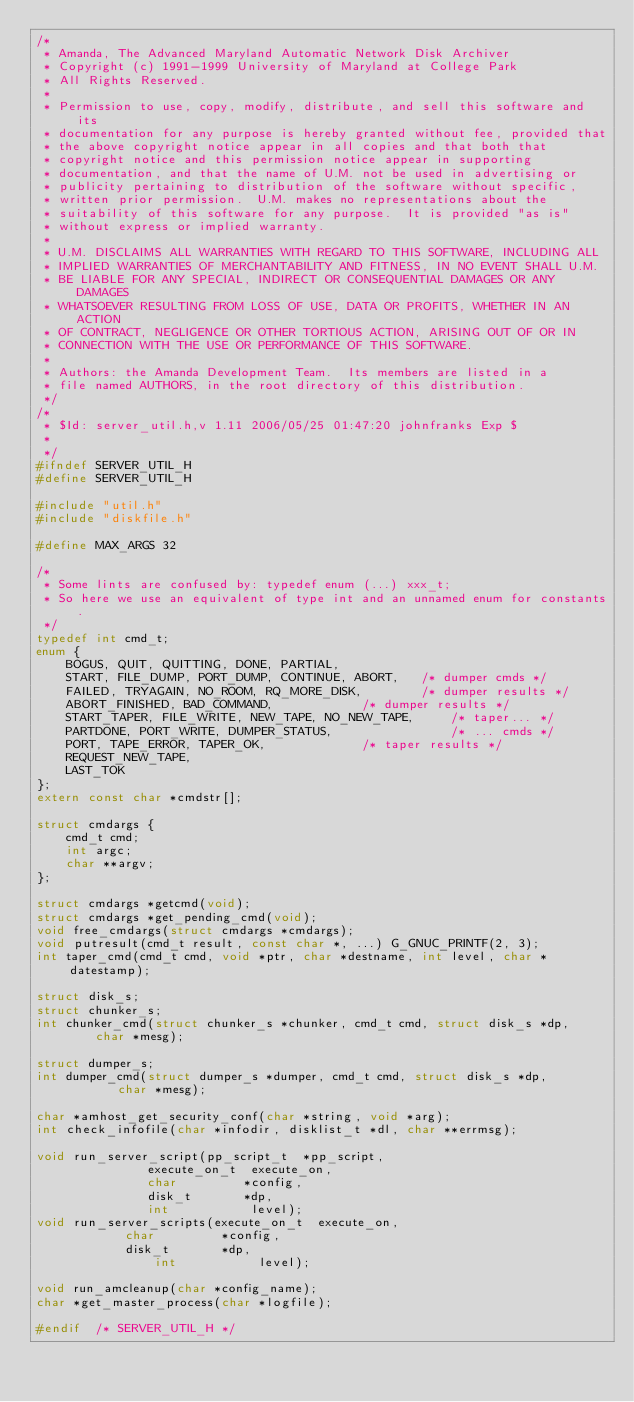<code> <loc_0><loc_0><loc_500><loc_500><_C_>/*
 * Amanda, The Advanced Maryland Automatic Network Disk Archiver
 * Copyright (c) 1991-1999 University of Maryland at College Park
 * All Rights Reserved.
 *
 * Permission to use, copy, modify, distribute, and sell this software and its
 * documentation for any purpose is hereby granted without fee, provided that
 * the above copyright notice appear in all copies and that both that
 * copyright notice and this permission notice appear in supporting
 * documentation, and that the name of U.M. not be used in advertising or
 * publicity pertaining to distribution of the software without specific,
 * written prior permission.  U.M. makes no representations about the
 * suitability of this software for any purpose.  It is provided "as is"
 * without express or implied warranty.
 *
 * U.M. DISCLAIMS ALL WARRANTIES WITH REGARD TO THIS SOFTWARE, INCLUDING ALL
 * IMPLIED WARRANTIES OF MERCHANTABILITY AND FITNESS, IN NO EVENT SHALL U.M.
 * BE LIABLE FOR ANY SPECIAL, INDIRECT OR CONSEQUENTIAL DAMAGES OR ANY DAMAGES
 * WHATSOEVER RESULTING FROM LOSS OF USE, DATA OR PROFITS, WHETHER IN AN ACTION
 * OF CONTRACT, NEGLIGENCE OR OTHER TORTIOUS ACTION, ARISING OUT OF OR IN
 * CONNECTION WITH THE USE OR PERFORMANCE OF THIS SOFTWARE.
 *
 * Authors: the Amanda Development Team.  Its members are listed in a
 * file named AUTHORS, in the root directory of this distribution.
 */
/*
 * $Id: server_util.h,v 1.11 2006/05/25 01:47:20 johnfranks Exp $
 *
 */
#ifndef SERVER_UTIL_H
#define	SERVER_UTIL_H

#include "util.h"
#include "diskfile.h"

#define MAX_ARGS 32

/*
 * Some lints are confused by: typedef enum (...) xxx_t;
 * So here we use an equivalent of type int and an unnamed enum for constants.
 */
typedef int cmd_t;
enum {
    BOGUS, QUIT, QUITTING, DONE, PARTIAL,
    START, FILE_DUMP, PORT_DUMP, CONTINUE, ABORT,	/* dumper cmds */
    FAILED, TRYAGAIN, NO_ROOM, RQ_MORE_DISK,		/* dumper results */
    ABORT_FINISHED, BAD_COMMAND,			/* dumper results */
    START_TAPER, FILE_WRITE, NEW_TAPE, NO_NEW_TAPE,     /* taper... */
    PARTDONE, PORT_WRITE, DUMPER_STATUS,                /* ... cmds */
    PORT, TAPE_ERROR, TAPER_OK,				/* taper results */
    REQUEST_NEW_TAPE,
    LAST_TOK
};
extern const char *cmdstr[];

struct cmdargs {
    cmd_t cmd;
    int argc;
    char **argv;
};

struct cmdargs *getcmd(void);
struct cmdargs *get_pending_cmd(void);
void free_cmdargs(struct cmdargs *cmdargs);
void putresult(cmd_t result, const char *, ...) G_GNUC_PRINTF(2, 3);
int taper_cmd(cmd_t cmd, void *ptr, char *destname, int level, char *datestamp);

struct disk_s;
struct chunker_s;
int chunker_cmd(struct chunker_s *chunker, cmd_t cmd, struct disk_s *dp,
		char *mesg);

struct dumper_s;
int dumper_cmd(struct dumper_s *dumper, cmd_t cmd, struct disk_s *dp,
	       char *mesg);

char *amhost_get_security_conf(char *string, void *arg);
int check_infofile(char *infodir, disklist_t *dl, char **errmsg);

void run_server_script(pp_script_t  *pp_script,
		       execute_on_t  execute_on,
		       char         *config,
		       disk_t       *dp,
		       int           level);
void run_server_scripts(execute_on_t  execute_on,
			char         *config,
			disk_t       *dp,
		        int           level);

void run_amcleanup(char *config_name);
char *get_master_process(char *logfile);

#endif	/* SERVER_UTIL_H */
</code> 